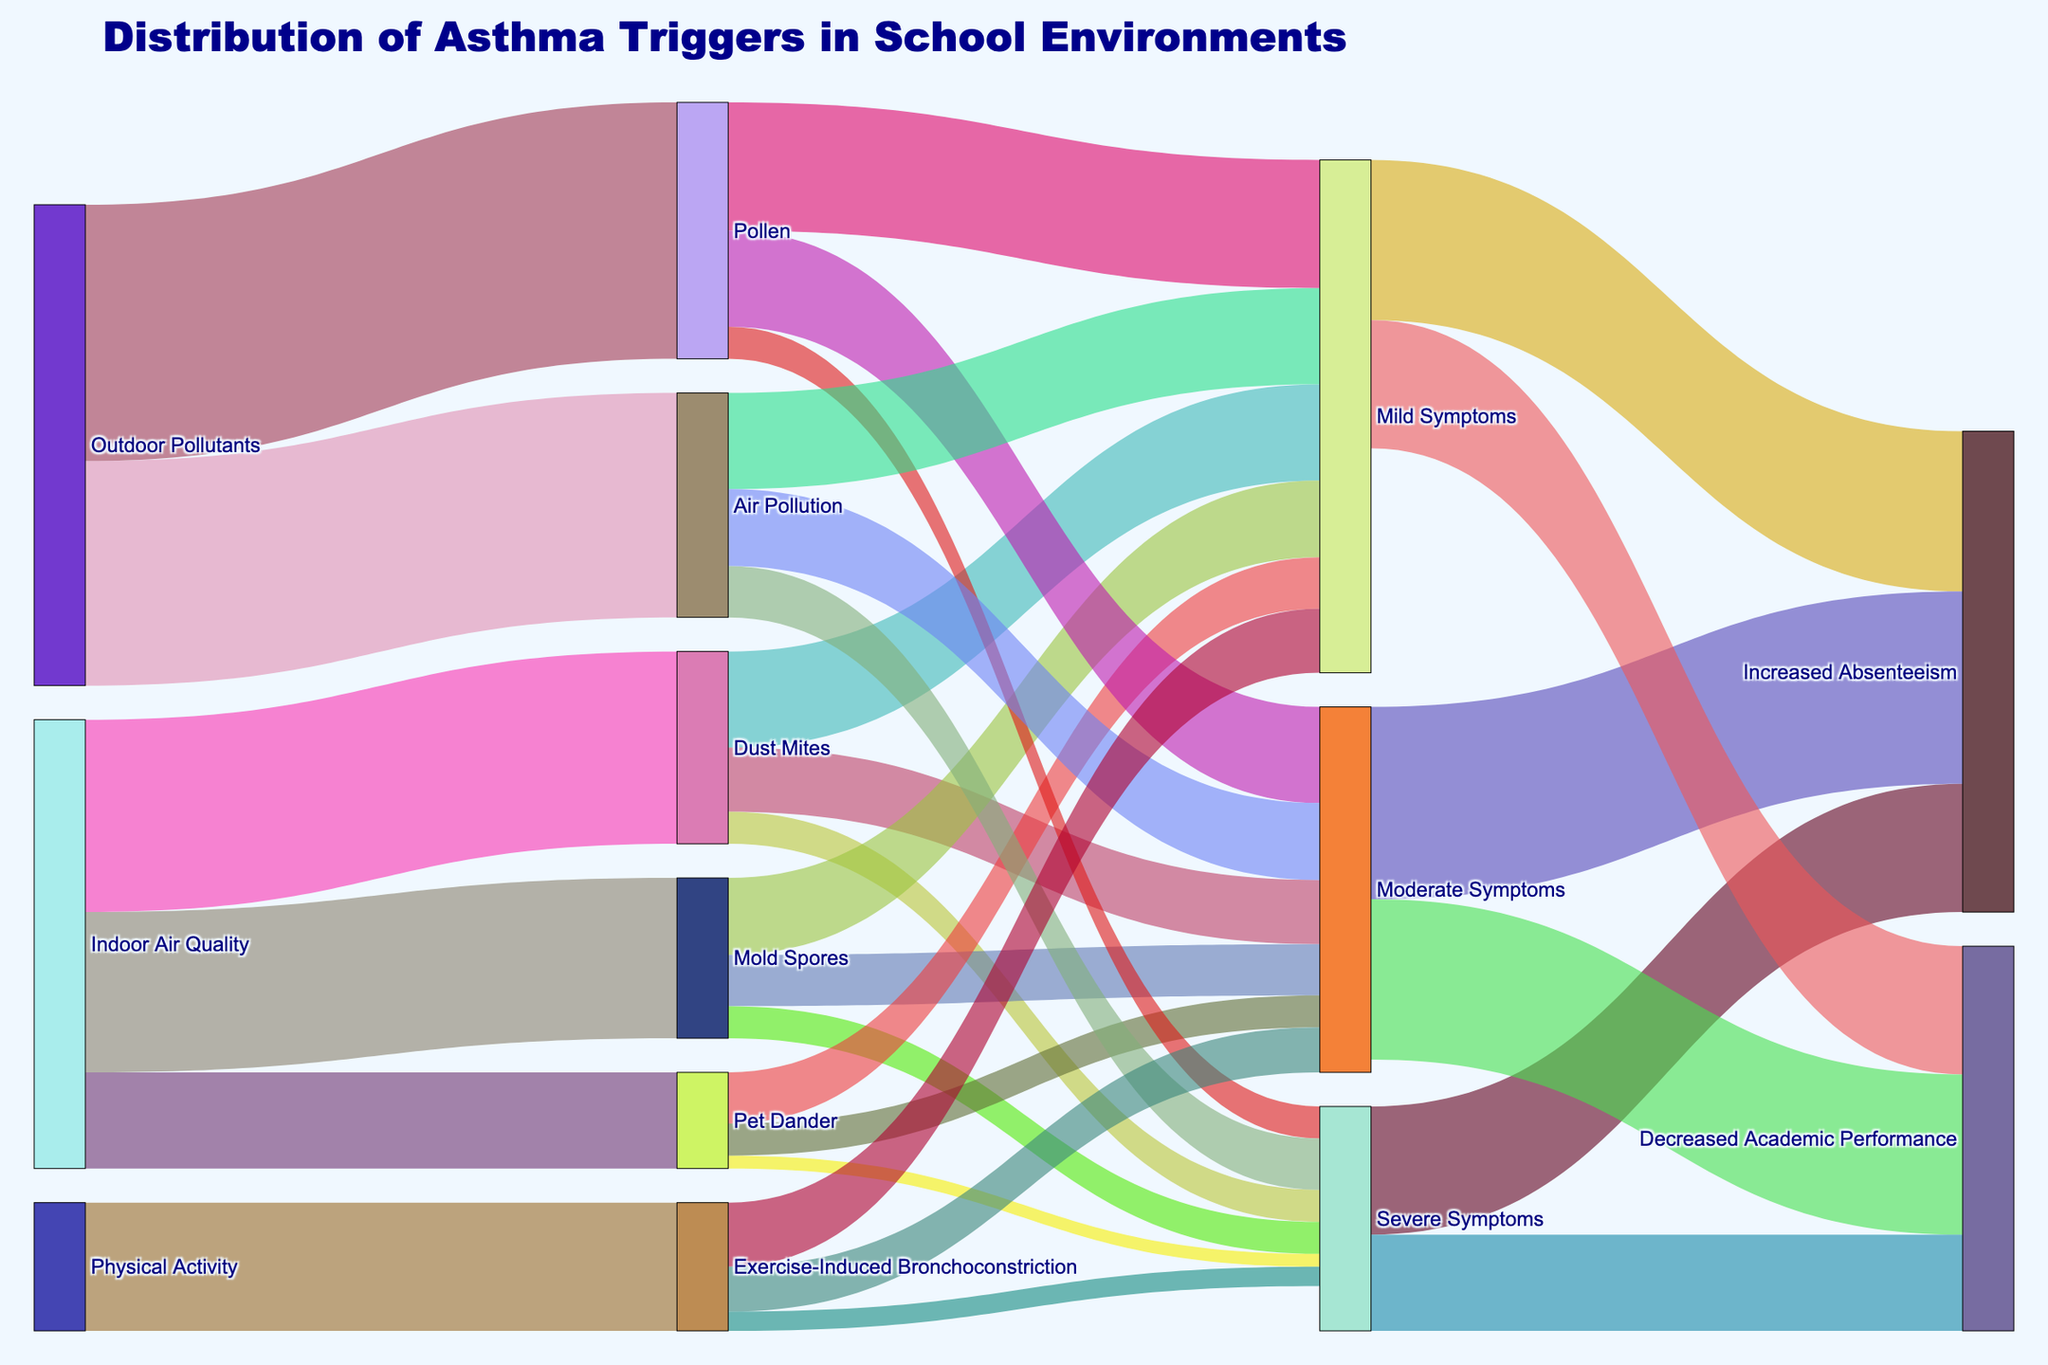Which source contributes most significantly to asthma triggers in the school environment? From the diagram, we can see that 'Outdoor Pollutants' has the largest sum of values when broken down, with 'Pollen' (40) and 'Air Pollution' (35) totaling 75. This is higher than contributions from 'Indoor Air Quality' (30 + 25 + 15 = 70) and 'Physical Activity' (20).
Answer: Outdoor Pollutants Which trigger leads to the highest number of severe symptoms? By summing up the values for severe symptoms, we find that 'Air Pollution' has the highest number (8), compared to other triggers like 'Pollen' (5), 'Dust Mites' (5), 'Mold Spores' (5), 'Pet Dander' (2), and 'Exercise-Induced Bronchoconstriction' (3).
Answer: Air Pollution How many total asthma triggers are identified in the school environment? According to the diagram, the identified triggers are 'Dust Mites', 'Mold Spores', 'Pet Dander', 'Pollen', 'Air Pollution', and 'Exercise-Induced Bronchoconstriction', which totals 6 triggers.
Answer: 6 Of the mild symptoms, which impact results in higher numbers: Increased Absenteeism or Decreased Academic Performance? The figure shows that 'Mild Symptoms' lead to 25 cases of 'Increased Absenteeism' and 20 of 'Decreased Academic Performance'. Therefore, 'Increased Absenteeism' is higher.
Answer: Increased Absenteeism What is the total number of moderate symptoms resulting from Indoor Air Quality-related triggers? Adding the values related to moderate symptoms for 'Dust Mites' (10), 'Mold Spores' (8), and 'Pet Dander' (5) totals 23.
Answer: 23 Is there a direct link between 'Physical Activity' and 'Severe Symptoms'? By tracing the connections in the Sankey Diagram, 'Physical Activity' leads directly to 'Exercise-Induced Bronchoconstriction' and from there to 'Severe Symptoms' with a value of 3. Hence, there is a direct link.
Answer: Yes Which asthma trigger shows the smallest impact on severe symptoms? Comparing the specified severe symptoms values from each trigger, 'Pet Dander' has the smallest impact with a value of 2.
Answer: Pet Dander What's the total value of asthma triggers related to 'Indoor Air Quality'? Summing up the specified values originating from 'Indoor Air Quality' (Dust Mites 30, Mold Spores 25, Pet Dander 15) gives a total of 70.
Answer: 70 How do the severe symptoms due to 'Mold Spores' compare to those due to 'Pollen'? From the diagram, 'Mold Spores' result in 5 severe symptoms which is equal to the 5 severe symptoms due to 'Pollen'.
Answer: Equal 